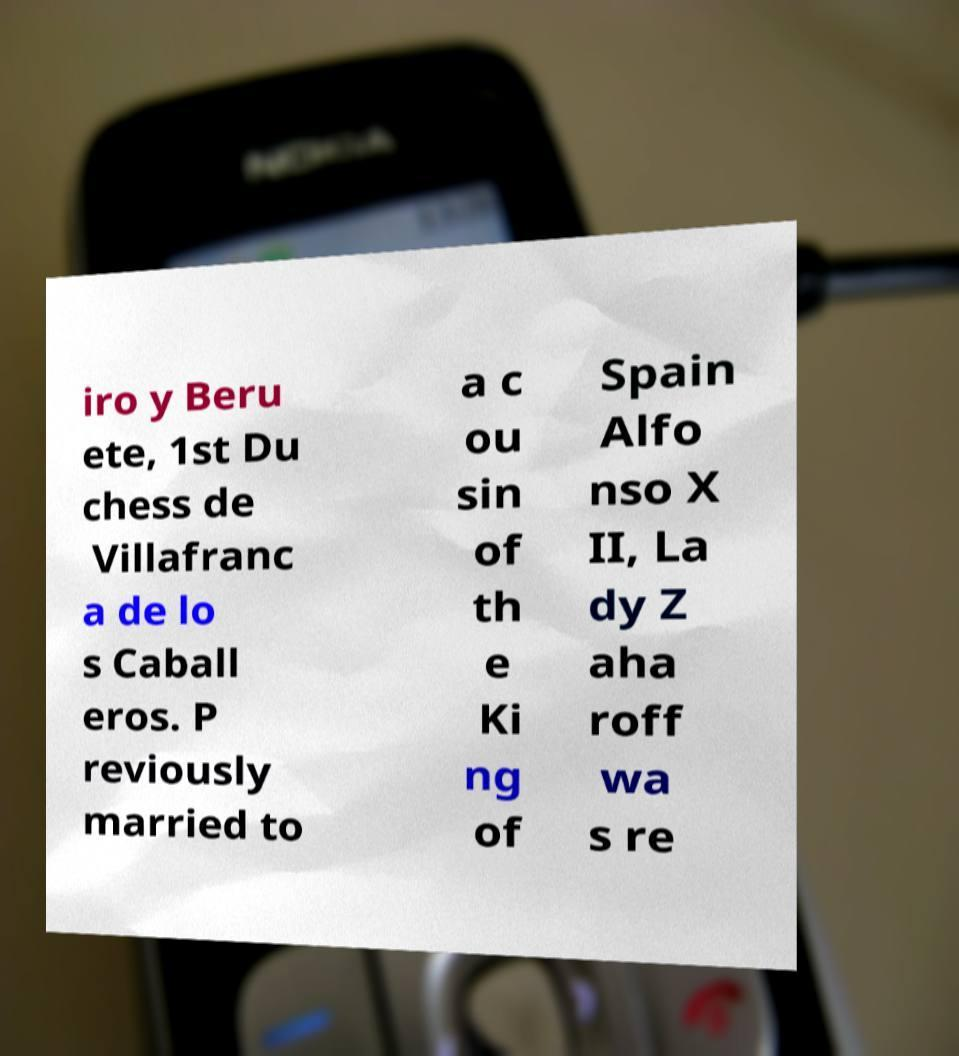Can you read and provide the text displayed in the image?This photo seems to have some interesting text. Can you extract and type it out for me? iro y Beru ete, 1st Du chess de Villafranc a de lo s Caball eros. P reviously married to a c ou sin of th e Ki ng of Spain Alfo nso X II, La dy Z aha roff wa s re 